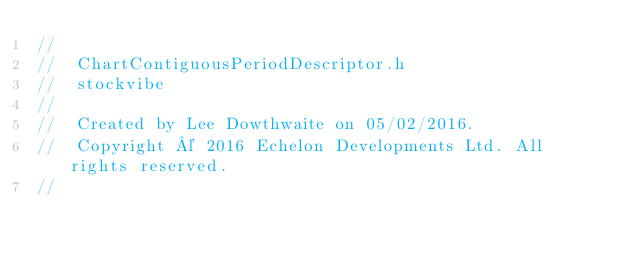Convert code to text. <code><loc_0><loc_0><loc_500><loc_500><_C_>//
//  ChartContiguousPeriodDescriptor.h
//  stockvibe
//
//  Created by Lee Dowthwaite on 05/02/2016.
//  Copyright © 2016 Echelon Developments Ltd. All rights reserved.
//
</code> 